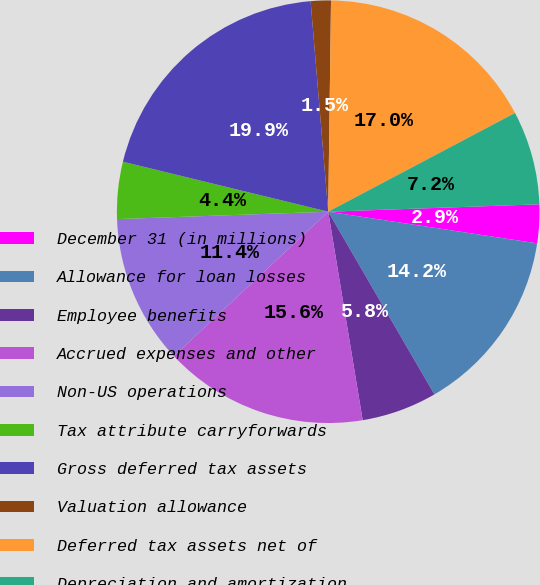<chart> <loc_0><loc_0><loc_500><loc_500><pie_chart><fcel>December 31 (in millions)<fcel>Allowance for loan losses<fcel>Employee benefits<fcel>Accrued expenses and other<fcel>Non-US operations<fcel>Tax attribute carryforwards<fcel>Gross deferred tax assets<fcel>Valuation allowance<fcel>Deferred tax assets net of<fcel>Depreciation and amortization<nl><fcel>2.95%<fcel>14.23%<fcel>5.77%<fcel>15.64%<fcel>11.41%<fcel>4.36%<fcel>19.87%<fcel>1.54%<fcel>17.05%<fcel>7.18%<nl></chart> 